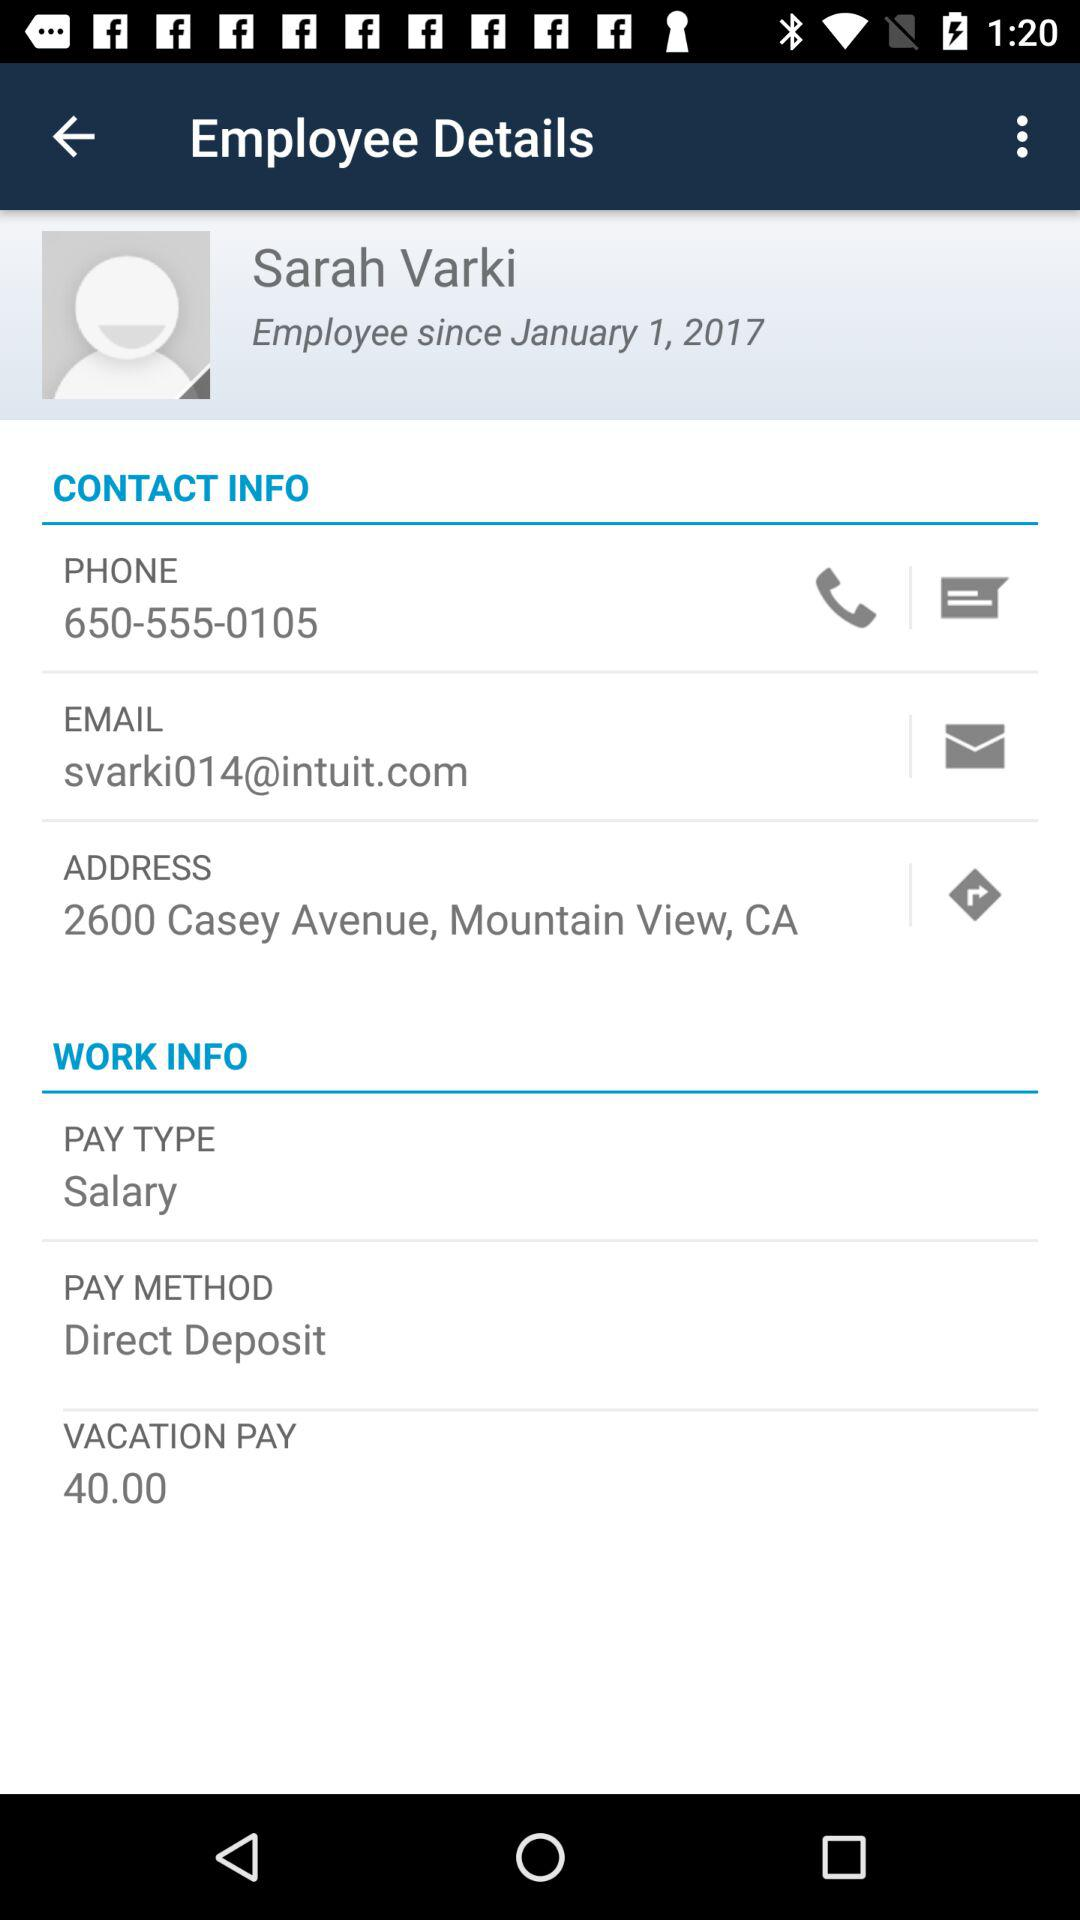What is the vacation pay? The vacation pay is 40. 